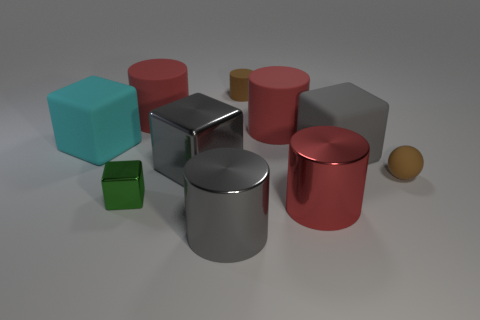There is a gray cylinder that is the same size as the cyan block; what is its material?
Keep it short and to the point. Metal. Are there any green rubber objects of the same shape as the red shiny thing?
Your answer should be compact. No. What is the shape of the gray matte object that is the same size as the cyan thing?
Offer a very short reply. Cube. The red rubber object that is on the left side of the big gray metal cylinder has what shape?
Make the answer very short. Cylinder. Is the number of green metal things that are in front of the big gray cylinder less than the number of red cylinders behind the tiny green object?
Provide a succinct answer. Yes. Does the green metallic cube have the same size as the thing on the left side of the green metallic object?
Your response must be concise. No. How many brown matte cylinders have the same size as the gray shiny cube?
Your answer should be compact. 0. There is another block that is the same material as the small green cube; what color is it?
Your answer should be very brief. Gray. Is the number of green cubes greater than the number of small brown rubber cubes?
Your answer should be very brief. Yes. Does the cyan object have the same material as the tiny brown cylinder?
Ensure brevity in your answer.  Yes. 